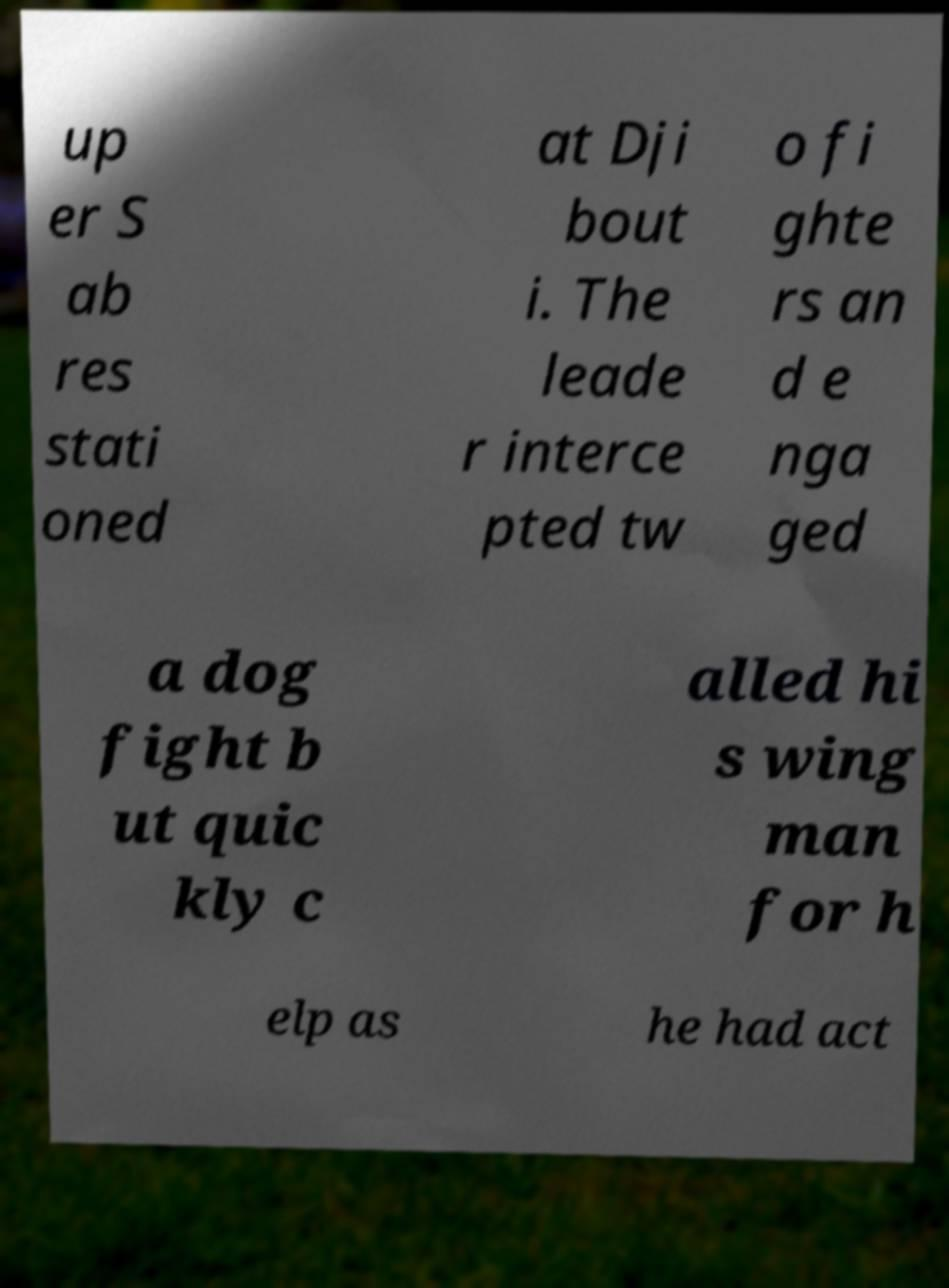For documentation purposes, I need the text within this image transcribed. Could you provide that? up er S ab res stati oned at Dji bout i. The leade r interce pted tw o fi ghte rs an d e nga ged a dog fight b ut quic kly c alled hi s wing man for h elp as he had act 